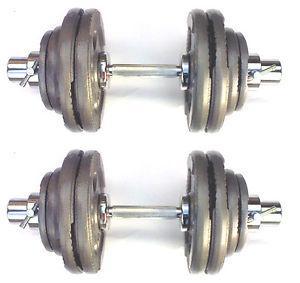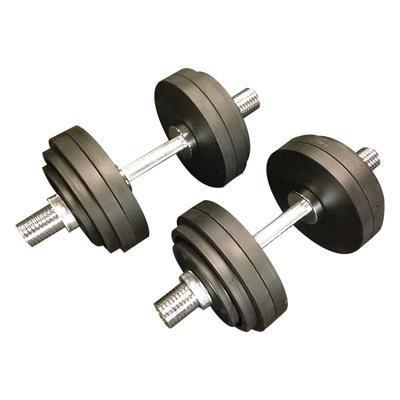The first image is the image on the left, the second image is the image on the right. Assess this claim about the two images: "One image includes at least 12 round black weights and two bars, and the other image features two chrome bars displayed parallel to each other, and a pair of wire clamp shapes next to them.". Correct or not? Answer yes or no. No. The first image is the image on the left, the second image is the image on the right. Examine the images to the left and right. Is the description "There are a total of four dumbbell bars with only two having weight on them." accurate? Answer yes or no. No. 